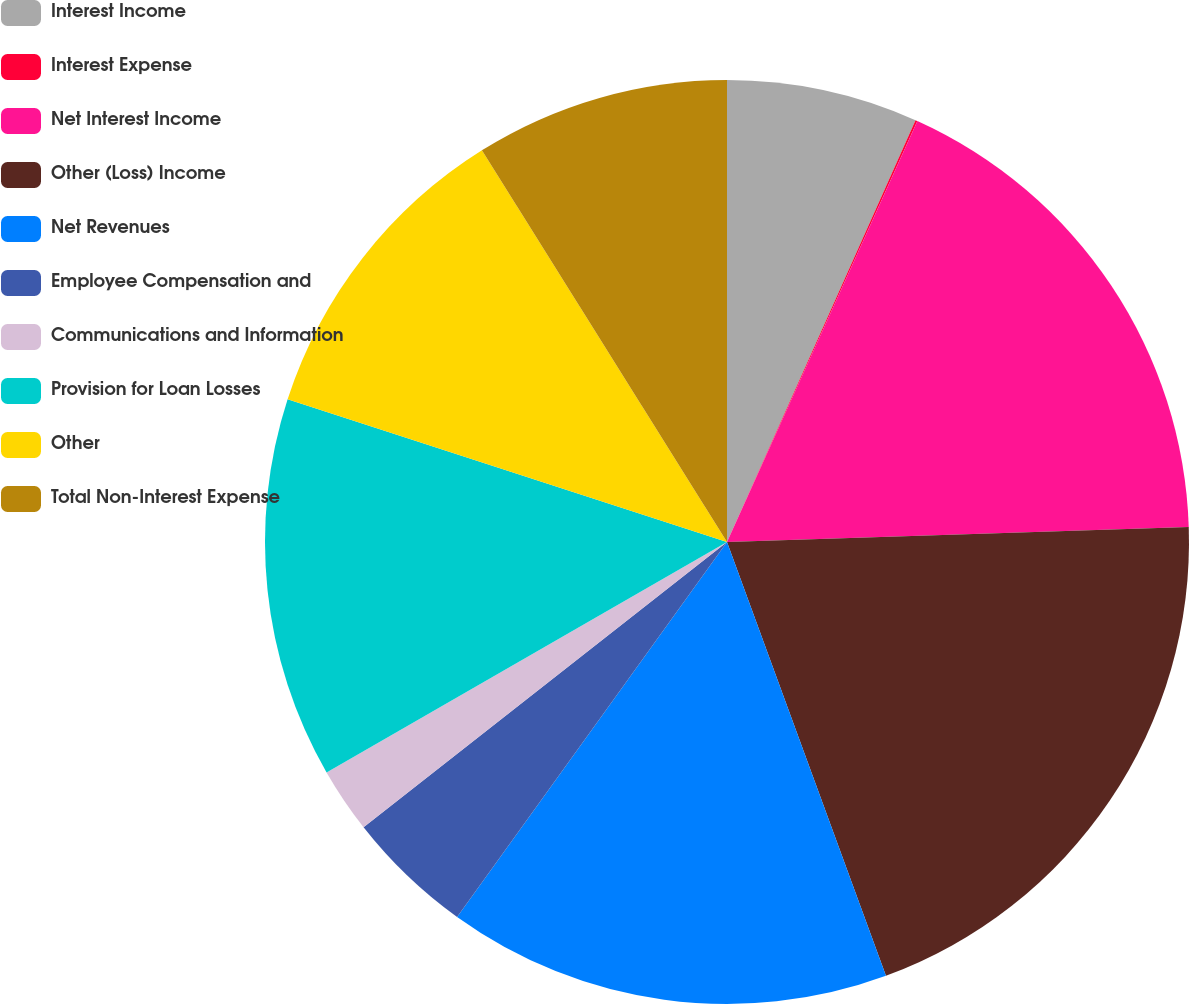Convert chart to OTSL. <chart><loc_0><loc_0><loc_500><loc_500><pie_chart><fcel>Interest Income<fcel>Interest Expense<fcel>Net Interest Income<fcel>Other (Loss) Income<fcel>Net Revenues<fcel>Employee Compensation and<fcel>Communications and Information<fcel>Provision for Loan Losses<fcel>Other<fcel>Total Non-Interest Expense<nl><fcel>6.69%<fcel>0.07%<fcel>17.72%<fcel>19.93%<fcel>15.52%<fcel>4.48%<fcel>2.28%<fcel>13.31%<fcel>11.1%<fcel>8.9%<nl></chart> 